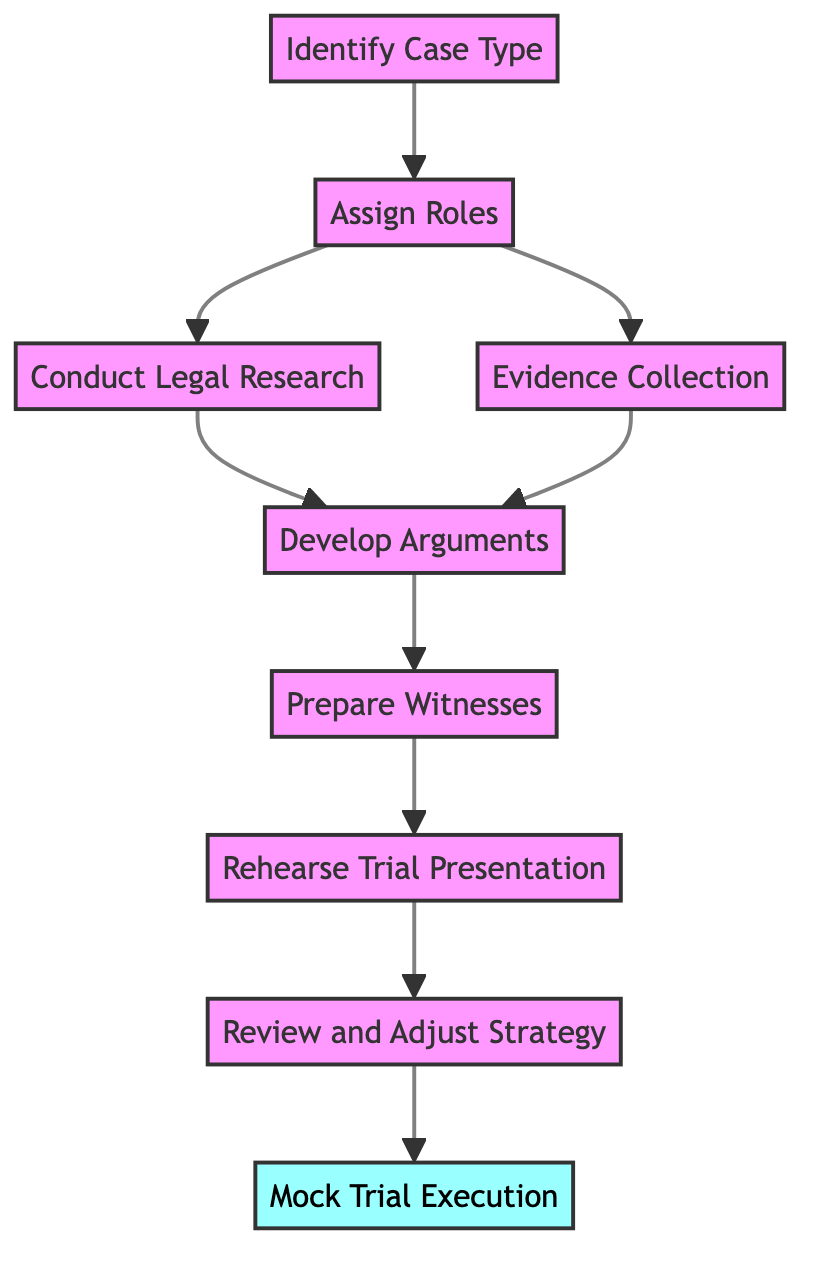What is the first step in the mock trial preparation process? The first step in the diagram is "Identify Case Type", which is depicted as the starting node and connects to other elements.
Answer: Identify Case Type How many roles are assigned in the mock trial preparation process? The diagram specifies that there are four roles defined: Lead Attorney, Defense Attorney, Witnesses, and Research Assistants, which are all part of the "Assign Roles" node.
Answer: Four What do you do after collecting evidence? After collecting evidence, the next step in the flow chart is to "Develop Arguments", indicating the sequence of actions.
Answer: Develop Arguments Which steps are directly associated with the "Assign Roles" node? The "Assign Roles" node directly leads to two nodes: "Conduct Legal Research" and "Evidence Collection", showing that both actions follow the assignment of roles.
Answer: Conduct Legal Research and Evidence Collection How many total steps are there in the mock trial preparation process? The diagram displays a total of nine steps, counting from "Identify Case Type" to "Mock Trial Execution".
Answer: Nine What happens after you rehearse the trial presentation? Following "Rehearse Trial Presentation," the next step detailed in the diagram is "Review and Adjust Strategy," showing this flow of activity.
Answer: Review and Adjust Strategy What is the final milestone in the mock trial preparation process? The diagram identifies "Mock Trial Execution" as the final node marked as a milestone, indicating the conclusion of the preparation.
Answer: Mock Trial Execution Which two critical processes happen simultaneously after assigning roles? Following "Assign Roles," two processes occur simultaneously – "Conduct Legal Research" and "Evidence Collection," as per the diagram's branching structure.
Answer: Conduct Legal Research and Evidence Collection What is the connecting step between developing arguments and preparing witnesses? The connecting step between "Develop Arguments" and "Prepare Witnesses" as represented in the flow chart is the preparation of arguments beforehand, indicating a logical sequence.
Answer: Prepare Witnesses Explain the relationship between evidence collection and argument development. The relationship is that both the "Evidence Collection" and "Conduct Legal Research" steps feed into "Develop Arguments", suggesting that evidence and research inform the creation of legal arguments.
Answer: Develop Arguments 